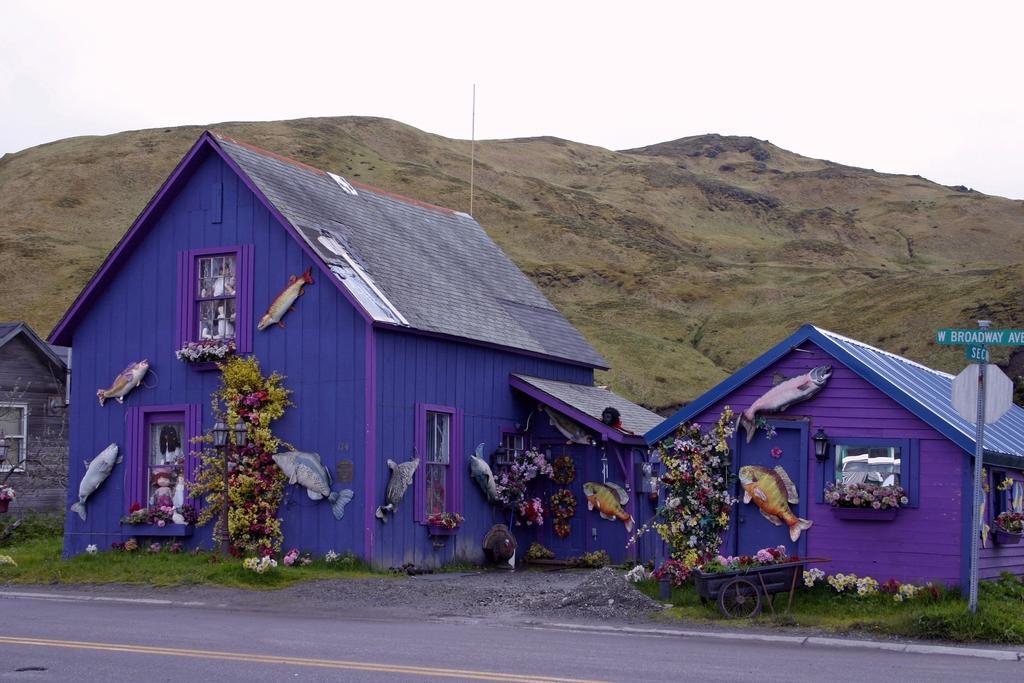How would you summarize this image in a sentence or two? Here we can see road,grass,plants and flowers and we can see fishes attached on house and board on pole. In the background we can see hill and sky. 